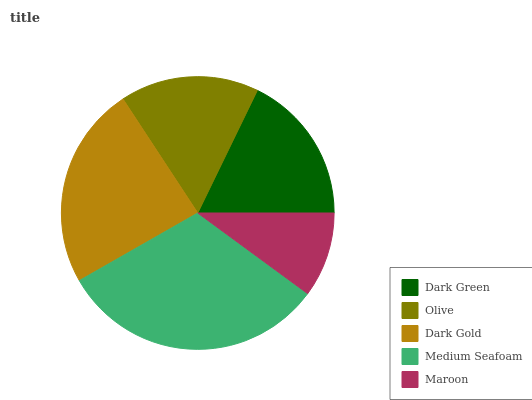Is Maroon the minimum?
Answer yes or no. Yes. Is Medium Seafoam the maximum?
Answer yes or no. Yes. Is Olive the minimum?
Answer yes or no. No. Is Olive the maximum?
Answer yes or no. No. Is Dark Green greater than Olive?
Answer yes or no. Yes. Is Olive less than Dark Green?
Answer yes or no. Yes. Is Olive greater than Dark Green?
Answer yes or no. No. Is Dark Green less than Olive?
Answer yes or no. No. Is Dark Green the high median?
Answer yes or no. Yes. Is Dark Green the low median?
Answer yes or no. Yes. Is Olive the high median?
Answer yes or no. No. Is Dark Gold the low median?
Answer yes or no. No. 